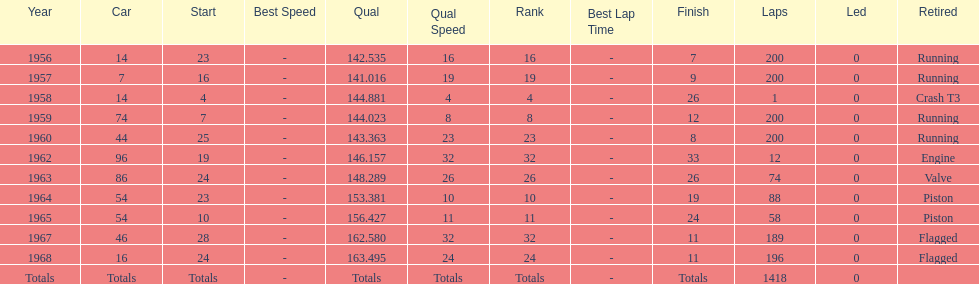How long did bob veith have the number 54 car at the indy 500? 2 years. 